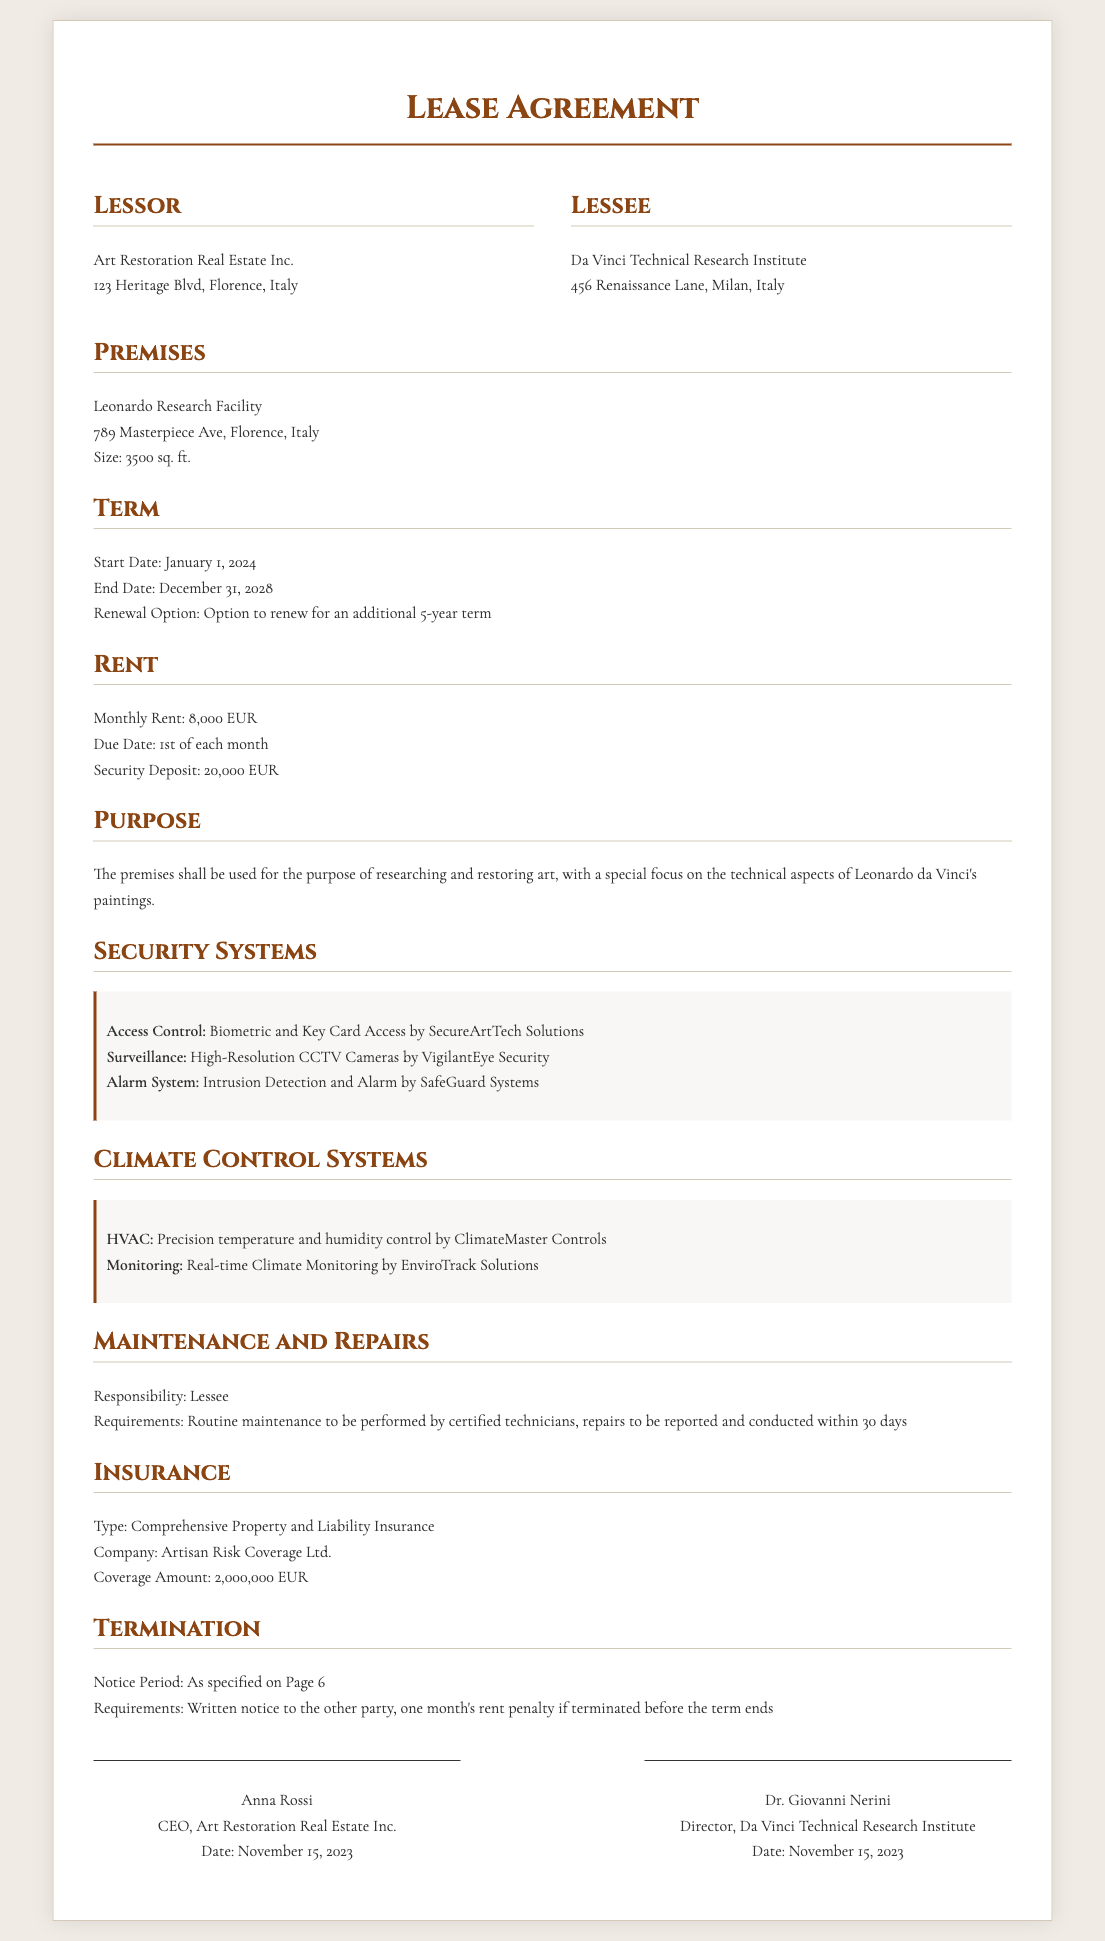What is the address of the lessor? The lessor's address is specified in the document as Art Restoration Real Estate Inc., 123 Heritage Blvd, Florence, Italy.
Answer: 123 Heritage Blvd, Florence, Italy What is the size of the premises? The size of the premises is detailed in the document, stating it is 3500 sq. ft.
Answer: 3500 sq. ft What is the monthly rent amount? The document specifies that the monthly rent is 8,000 EUR.
Answer: 8,000 EUR What is the start date of the lease? The start date of the lease is stated as January 1, 2024, in the Term section.
Answer: January 1, 2024 What type of insurance is required? The required insurance type is Comprehensive Property and Liability Insurance as outlined in the document.
Answer: Comprehensive Property and Liability Insurance Who is responsible for maintenance and repairs? The responsibility for maintenance and repairs falls under the lessee according to the Maintenance and Repairs section.
Answer: Lessee What is the coverage amount for insurance? The document specifies the coverage amount as 2,000,000 EUR.
Answer: 2,000,000 EUR What is included in the security systems? The security systems include biometric access control, high-resolution CCTV cameras, and intrusion detection alarms as detailed in the Security Systems section.
Answer: Biometric and Key Card Access, High-Resolution CCTV Cameras, Intrusion Detection and Alarm What happens if the lease is terminated early? If the lease is terminated before the term ends, there is a rent penalty specified in the Termination section.
Answer: One month's rent penalty 